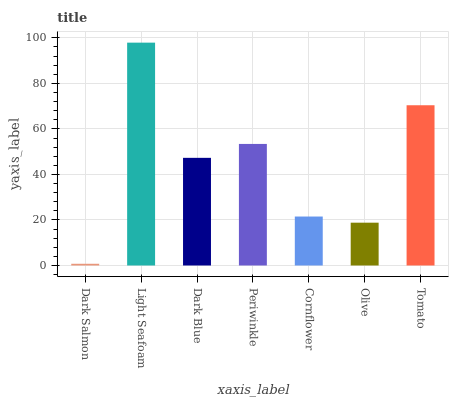Is Dark Salmon the minimum?
Answer yes or no. Yes. Is Light Seafoam the maximum?
Answer yes or no. Yes. Is Dark Blue the minimum?
Answer yes or no. No. Is Dark Blue the maximum?
Answer yes or no. No. Is Light Seafoam greater than Dark Blue?
Answer yes or no. Yes. Is Dark Blue less than Light Seafoam?
Answer yes or no. Yes. Is Dark Blue greater than Light Seafoam?
Answer yes or no. No. Is Light Seafoam less than Dark Blue?
Answer yes or no. No. Is Dark Blue the high median?
Answer yes or no. Yes. Is Dark Blue the low median?
Answer yes or no. Yes. Is Dark Salmon the high median?
Answer yes or no. No. Is Tomato the low median?
Answer yes or no. No. 